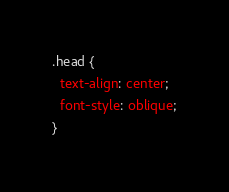<code> <loc_0><loc_0><loc_500><loc_500><_CSS_>.head {
  text-align: center;
  font-style: oblique;
}
</code> 